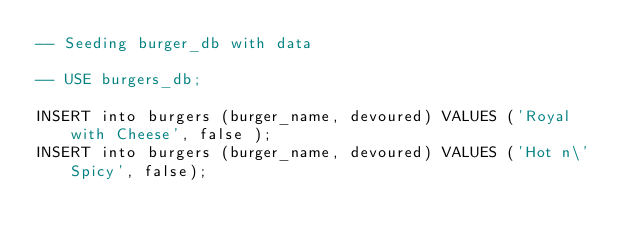<code> <loc_0><loc_0><loc_500><loc_500><_SQL_>-- Seeding burger_db with data 

-- USE burgers_db; 

INSERT into burgers (burger_name, devoured) VALUES ('Royal with Cheese', false ); 
INSERT into burgers (burger_name, devoured) VALUES ('Hot n\' Spicy', false);</code> 